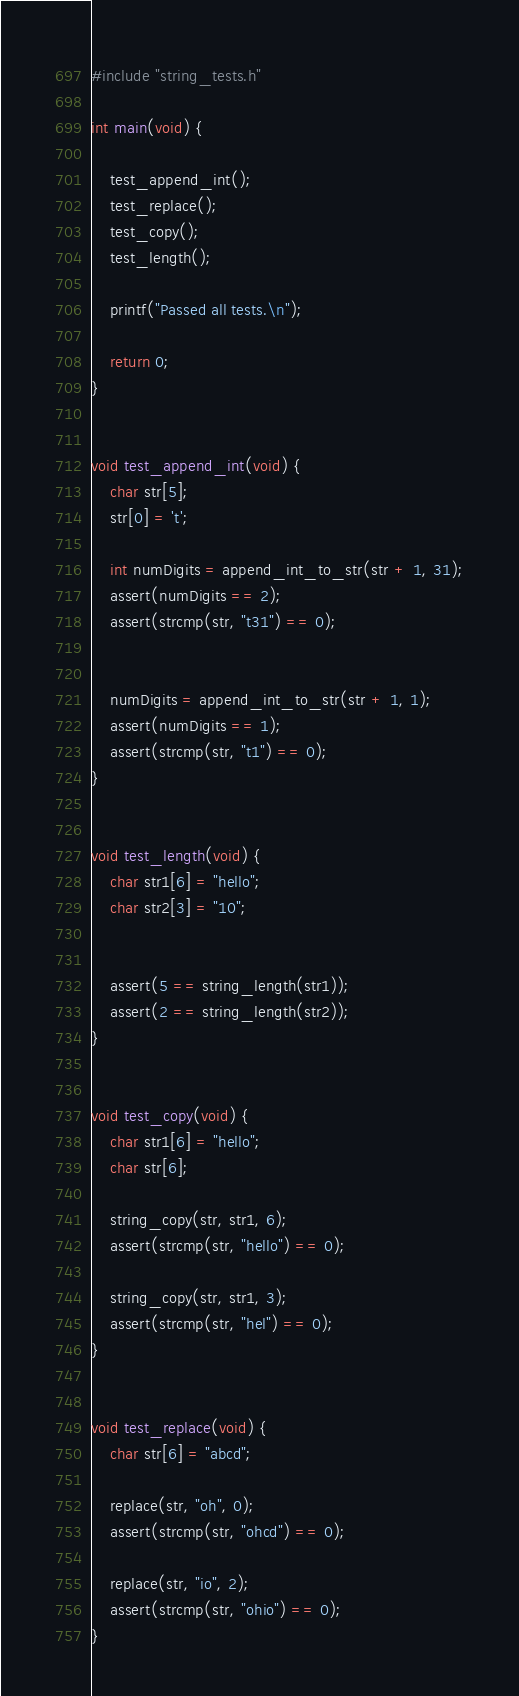<code> <loc_0><loc_0><loc_500><loc_500><_C_>#include "string_tests.h"

int main(void) {

    test_append_int();
    test_replace();
    test_copy();
    test_length();

    printf("Passed all tests.\n");

    return 0;
}


void test_append_int(void) {
    char str[5];
    str[0] = 't';

    int numDigits = append_int_to_str(str + 1, 31);
    assert(numDigits == 2);
    assert(strcmp(str, "t31") == 0);


    numDigits = append_int_to_str(str + 1, 1);
    assert(numDigits == 1);
    assert(strcmp(str, "t1") == 0);
}


void test_length(void) {
    char str1[6] = "hello";
    char str2[3] = "10";


    assert(5 == string_length(str1));
    assert(2 == string_length(str2));
}


void test_copy(void) {
    char str1[6] = "hello";
    char str[6];

    string_copy(str, str1, 6);
    assert(strcmp(str, "hello") == 0);
    
    string_copy(str, str1, 3);
    assert(strcmp(str, "hel") == 0);
}


void test_replace(void) {
    char str[6] = "abcd";

    replace(str, "oh", 0);
    assert(strcmp(str, "ohcd") == 0);

    replace(str, "io", 2);    
    assert(strcmp(str, "ohio") == 0);
}
</code> 